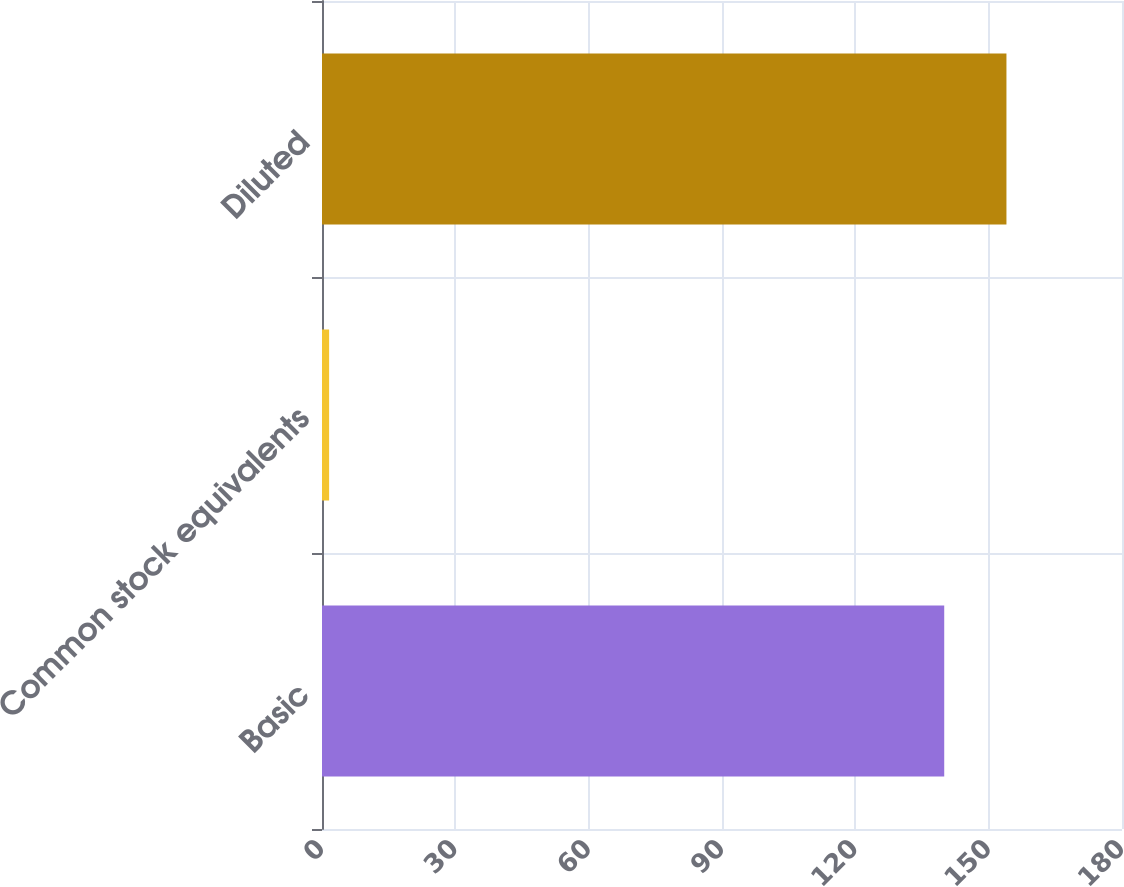Convert chart to OTSL. <chart><loc_0><loc_0><loc_500><loc_500><bar_chart><fcel>Basic<fcel>Common stock equivalents<fcel>Diluted<nl><fcel>140<fcel>1.6<fcel>154<nl></chart> 